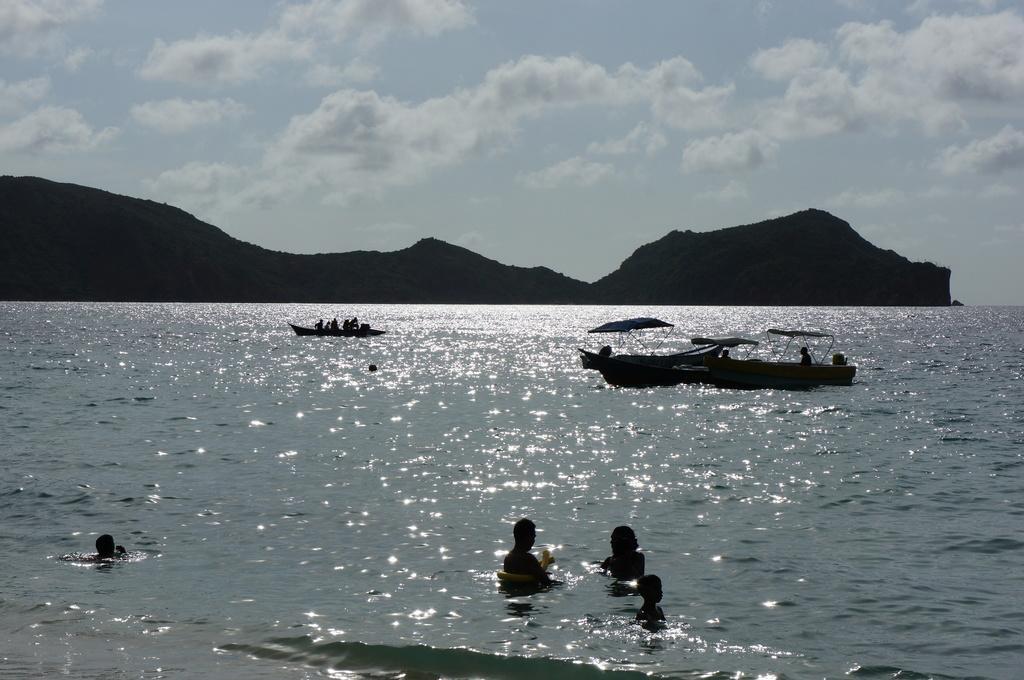In one or two sentences, can you explain what this image depicts? In the image there is a sea and some people were swimming and few boats were sailing on the sea, in the background there are few mountains. 